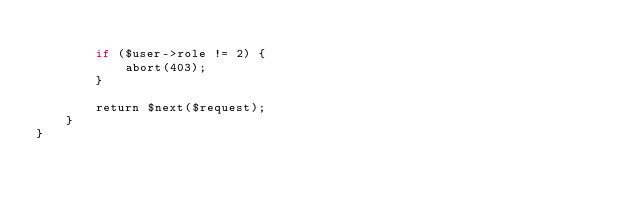Convert code to text. <code><loc_0><loc_0><loc_500><loc_500><_PHP_>
        if ($user->role != 2) {
            abort(403);
        }

        return $next($request);
    }
}
</code> 